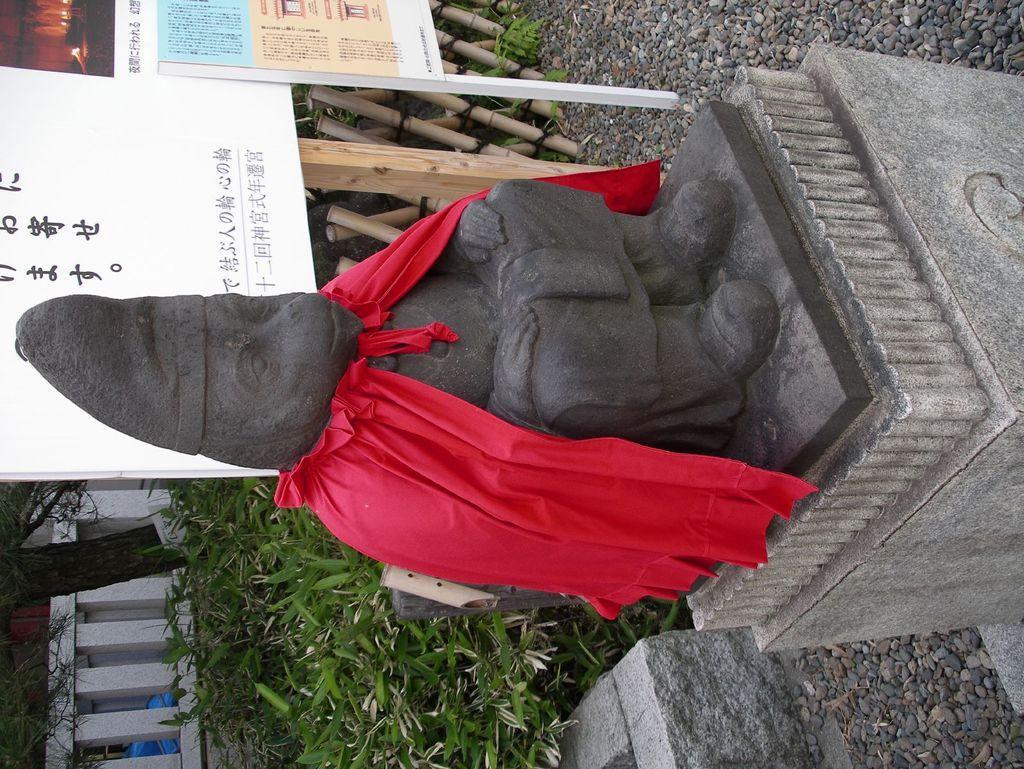Could you give a brief overview of what you see in this image? This is a rotated image. In this image we can see there is a statue, behind the statue there is grass, trees, railing and building, beside the statue there are a few banners and some wooden sticks arranged on the surface of the rocks. 